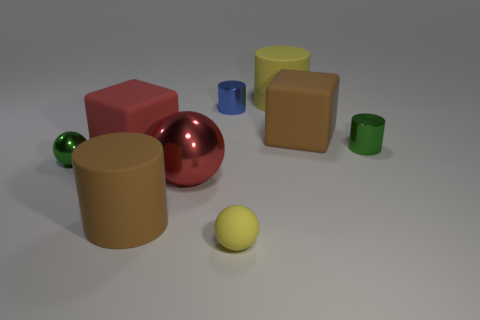Add 1 big brown rubber objects. How many objects exist? 10 Subtract all cubes. How many objects are left? 7 Subtract 1 yellow cylinders. How many objects are left? 8 Subtract all big red blocks. Subtract all small yellow shiny things. How many objects are left? 8 Add 7 shiny spheres. How many shiny spheres are left? 9 Add 6 blue metallic cylinders. How many blue metallic cylinders exist? 7 